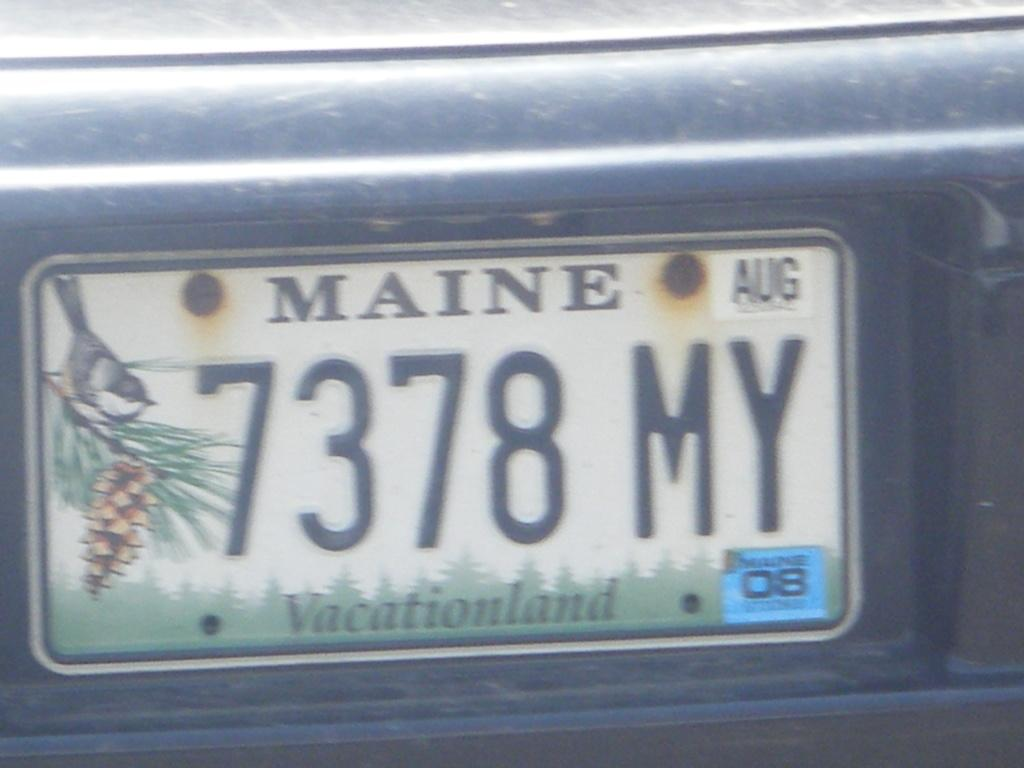<image>
Relay a brief, clear account of the picture shown. Vacationland is the state motto of Maine according to its license plate 